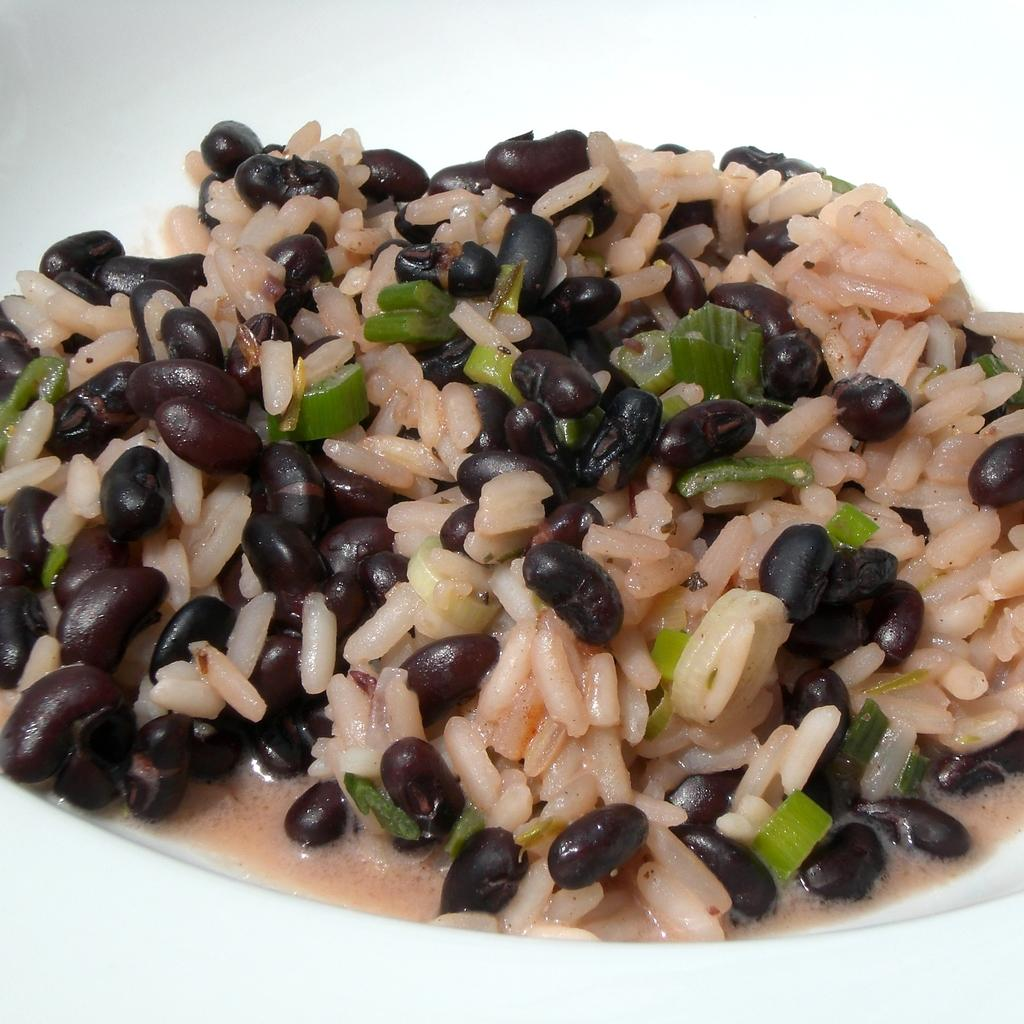What is the main subject of the image? There is an edible in the image. How is the edible presented in the image? The edible is placed on a white plate. What type of animal is guiding the edible in the image? There is no animal present in the image, and the edible is not being guided by any creature. 